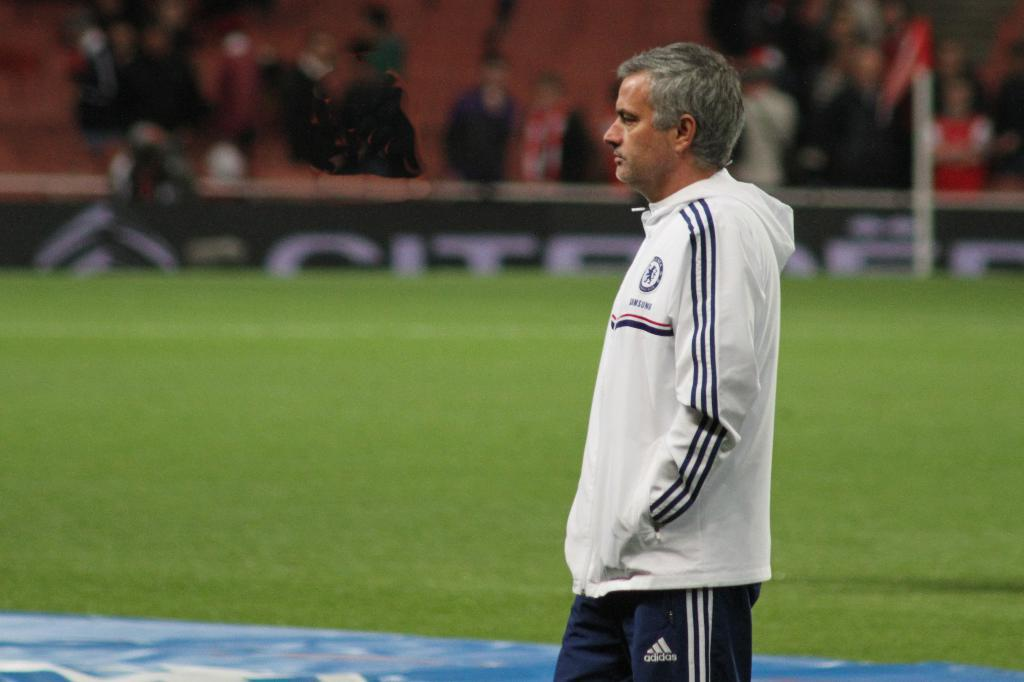Who is present in the image? There is a man in the image. What can be seen in the background of the image? There is grass and a group of people in the background of the image. How is the background of the image depicted? The background appears blurry. What type of holiday is being celebrated in the image? There is no indication of a holiday being celebrated in the image. Where is the table located in the image? There is no table present in the image. 